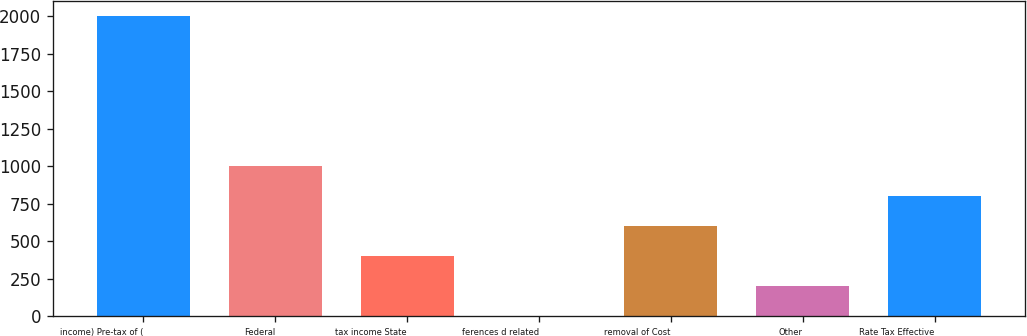Convert chart. <chart><loc_0><loc_0><loc_500><loc_500><bar_chart><fcel>income) Pre-tax of (<fcel>Federal<fcel>tax income State<fcel>ferences d related<fcel>removal of Cost<fcel>Other<fcel>Rate Tax Effective<nl><fcel>2005<fcel>1003.5<fcel>402.6<fcel>2<fcel>602.9<fcel>202.3<fcel>803.2<nl></chart> 